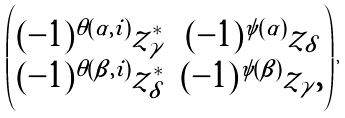Convert formula to latex. <formula><loc_0><loc_0><loc_500><loc_500>\begin{pmatrix} ( - 1 ) ^ { \theta ( \alpha , i ) } z ^ { * } _ { \gamma } & ( - 1 ) ^ { \psi ( \alpha ) } z _ { \delta } \\ ( - 1 ) ^ { \theta ( \beta , i ) } z ^ { * } _ { \delta } & ( - 1 ) ^ { \psi ( \beta ) } z _ { \gamma } , \end{pmatrix} ,</formula> 